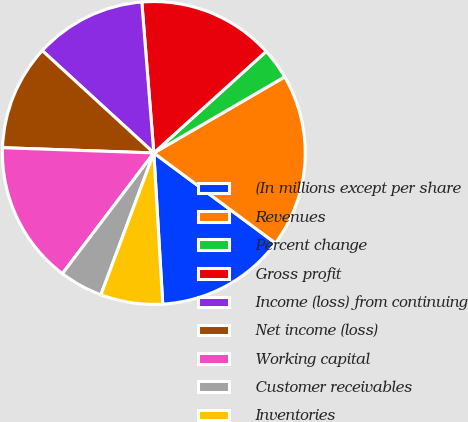<chart> <loc_0><loc_0><loc_500><loc_500><pie_chart><fcel>(In millions except per share<fcel>Revenues<fcel>Percent change<fcel>Gross profit<fcel>Income (loss) from continuing<fcel>Net income (loss)<fcel>Working capital<fcel>Customer receivables<fcel>Inventories<nl><fcel>13.91%<fcel>18.54%<fcel>3.31%<fcel>14.57%<fcel>11.92%<fcel>11.26%<fcel>15.23%<fcel>4.64%<fcel>6.62%<nl></chart> 